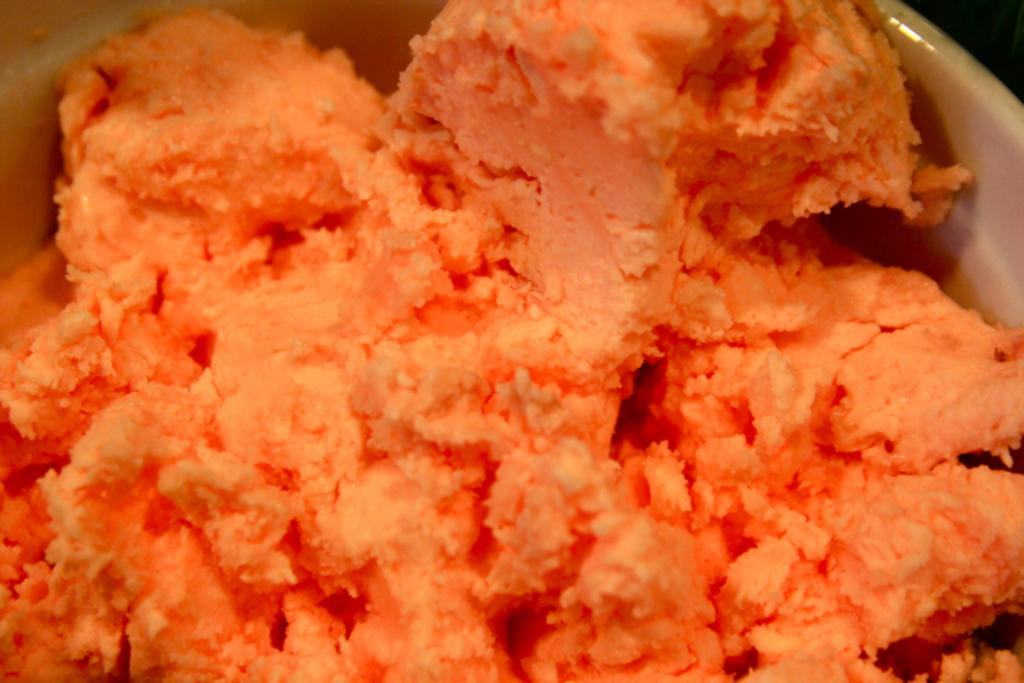What is in the bowl that is visible in the image? There is a bowl of ice cream in the image. What type of science experiment is being conducted with the ice cream in the image? There is no science experiment being conducted with the ice cream in the image; it is simply a bowl of ice cream. How many frogs can be seen interacting with the ice cream in the image? There are no frogs present in the image, and therefore no interaction with the ice cream can be observed. 